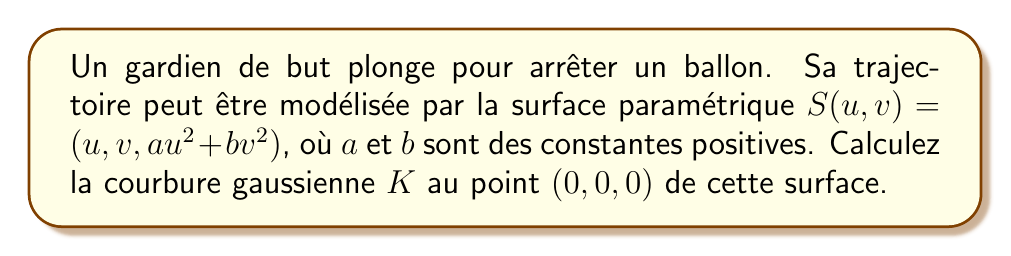Provide a solution to this math problem. Pour calculer la courbure gaussienne, nous allons suivre ces étapes :

1. Calculons les dérivées partielles de premier ordre :
   $$S_u = (1, 0, 2au)$$
   $$S_v = (0, 1, 2bv)$$

2. Calculons les dérivées partielles de second ordre :
   $$S_{uu} = (0, 0, 2a)$$
   $$S_{vv} = (0, 0, 2b)$$
   $$S_{uv} = S_{vu} = (0, 0, 0)$$

3. Au point $(0,0,0)$, ces vecteurs deviennent :
   $$S_u = (1, 0, 0)$$
   $$S_v = (0, 1, 0)$$
   $$S_{uu} = (0, 0, 2a)$$
   $$S_{vv} = (0, 0, 2b)$$
   $$S_{uv} = S_{vu} = (0, 0, 0)$$

4. Calculons la normale unitaire à la surface :
   $$N = \frac{S_u \times S_v}{|S_u \times S_v|} = (0, 0, 1)$$

5. Calculons les coefficients de la première forme fondamentale :
   $$E = S_u \cdot S_u = 1$$
   $$F = S_u \cdot S_v = 0$$
   $$G = S_v \cdot S_v = 1$$

6. Calculons les coefficients de la seconde forme fondamentale :
   $$L = S_{uu} \cdot N = 2a$$
   $$M = S_{uv} \cdot N = 0$$
   $$N = S_{vv} \cdot N = 2b$$

7. La courbure gaussienne est donnée par :
   $$K = \frac{LN - M^2}{EG - F^2}$$

8. En substituant les valeurs :
   $$K = \frac{(2a)(2b) - 0^2}{(1)(1) - 0^2} = 4ab$$

Donc, la courbure gaussienne au point $(0,0,0)$ est $4ab$.
Answer: $K = 4ab$ 